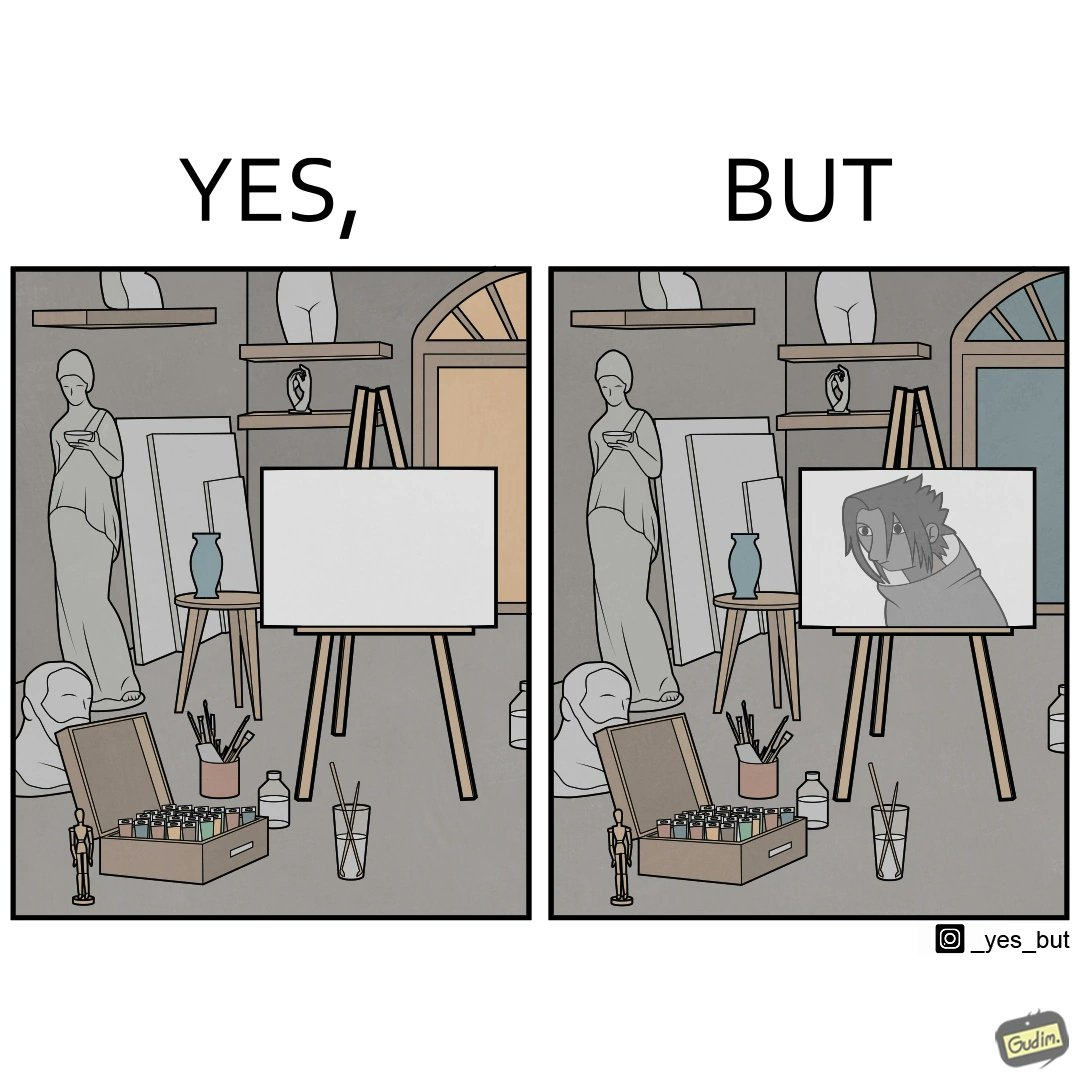Is there satirical content in this image? Yes, this image is satirical. 